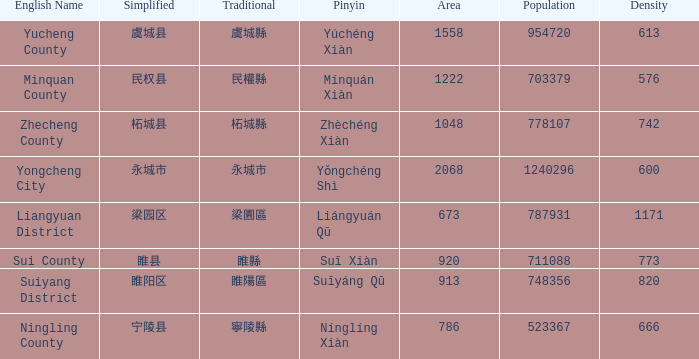What is the traditional form for 宁陵县? 寧陵縣. 